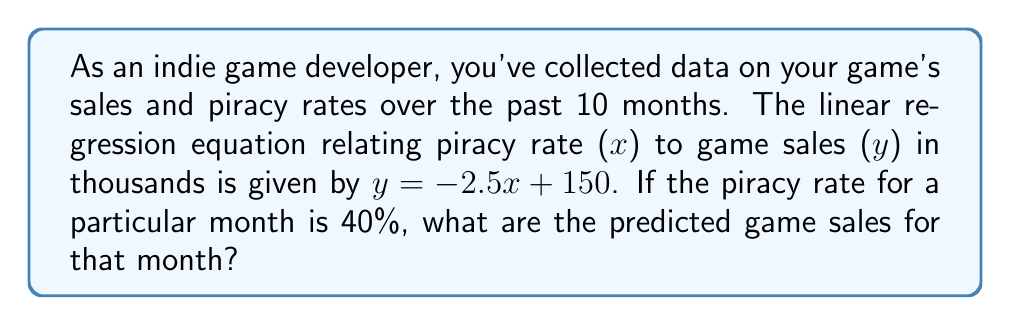Can you solve this math problem? To solve this problem, we'll follow these steps:

1) We're given the linear regression equation:
   $$y = -2.5x + 150$$
   where $y$ represents game sales in thousands and $x$ represents the piracy rate as a decimal.

2) We need to convert the given piracy rate from a percentage to a decimal:
   40% = 0.40

3) Now, we substitute $x = 0.40$ into our equation:
   $$y = -2.5(0.40) + 150$$

4) Let's solve this step-by-step:
   $$y = -1 + 150$$
   $$y = 149$$

5) Remember that $y$ represents sales in thousands, so our final answer is 149,000 sales.
Answer: 149,000 sales 